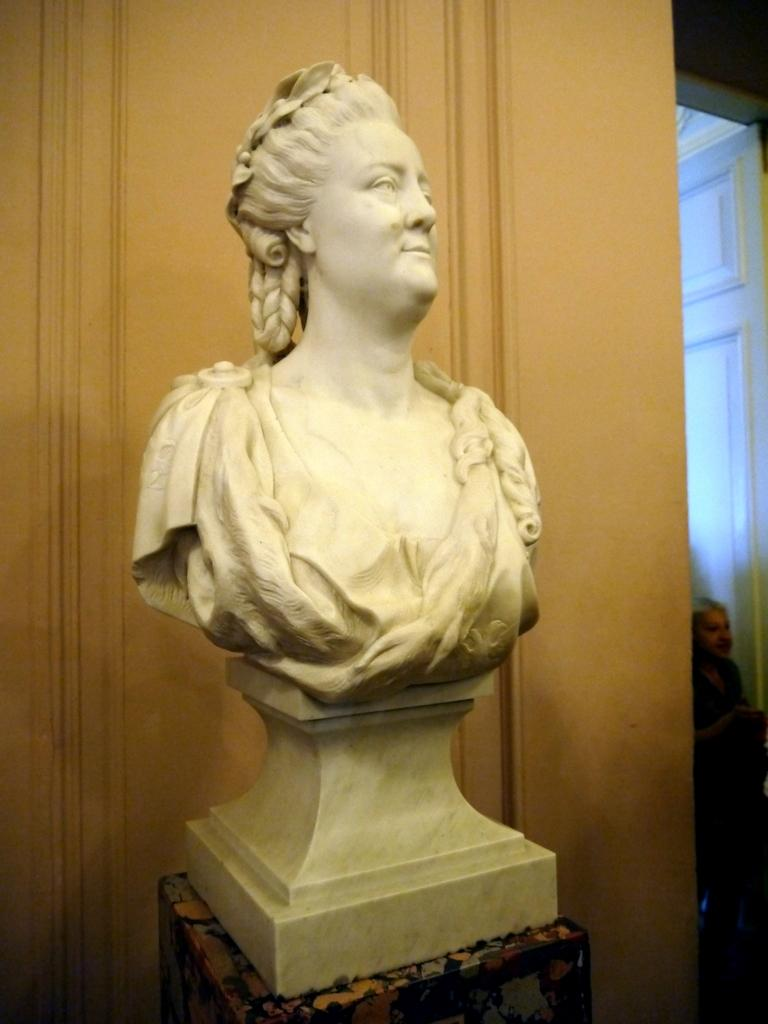What is the main subject in the center of the image? There is a statue in the center of the image. What can be seen behind the statue? There is a well behind the statue. Where is the door located in the image? There is a door on the right side of the image. Is there anyone near the door? Yes, there is a person near the door. What news does the son deliver to the person near the door in the image? There is no son or news present in the image; it only features a statue, a well, a door, and a person. 